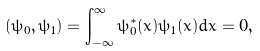Convert formula to latex. <formula><loc_0><loc_0><loc_500><loc_500>( \psi _ { 0 } , \psi _ { 1 } ) = \int _ { - \infty } ^ { \infty } \psi _ { 0 } ^ { * } ( x ) \psi _ { 1 } ( x ) d x = 0 ,</formula> 